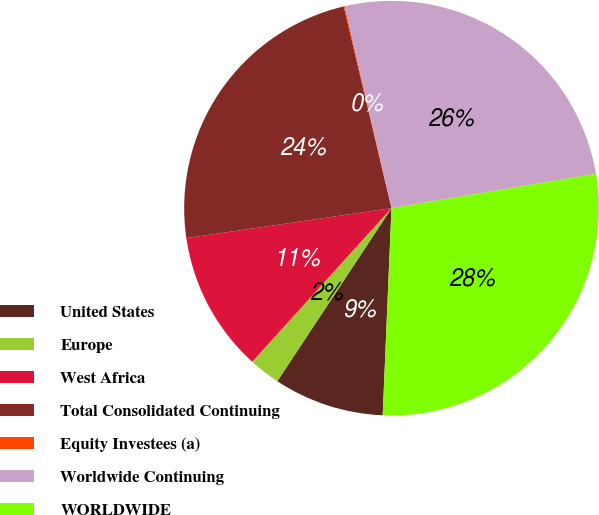<chart> <loc_0><loc_0><loc_500><loc_500><pie_chart><fcel>United States<fcel>Europe<fcel>West Africa<fcel>Total Consolidated Continuing<fcel>Equity Investees (a)<fcel>Worldwide Continuing<fcel>WORLDWIDE<nl><fcel>8.61%<fcel>2.44%<fcel>10.97%<fcel>23.61%<fcel>0.08%<fcel>25.97%<fcel>28.33%<nl></chart> 